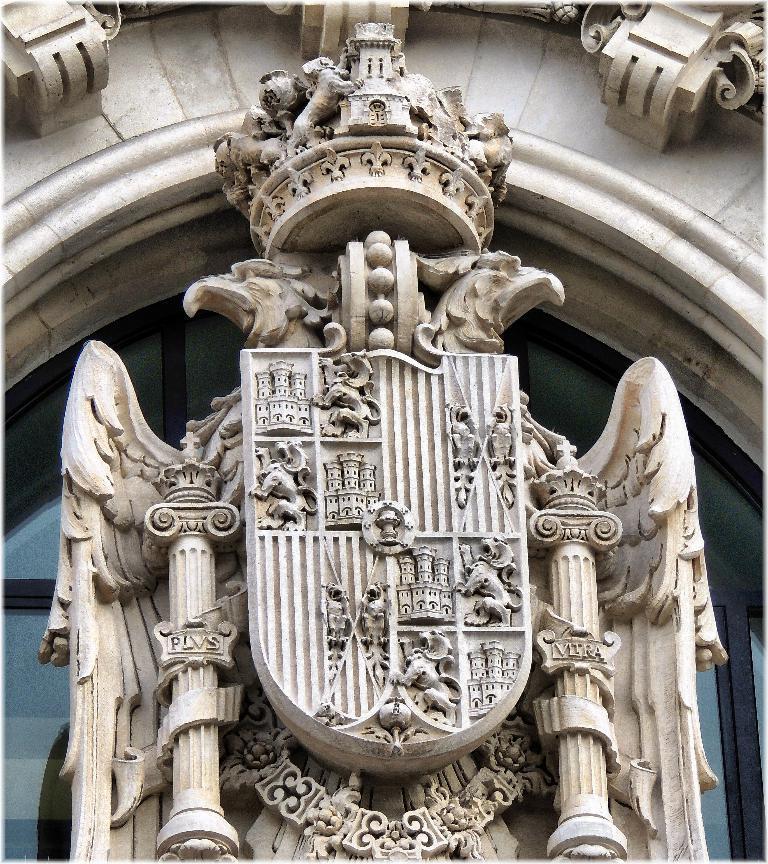Describe this image in one or two sentences. In the picture I can see sculptures in the shape of animals and some other things. In the background I can see framed glass wall. 